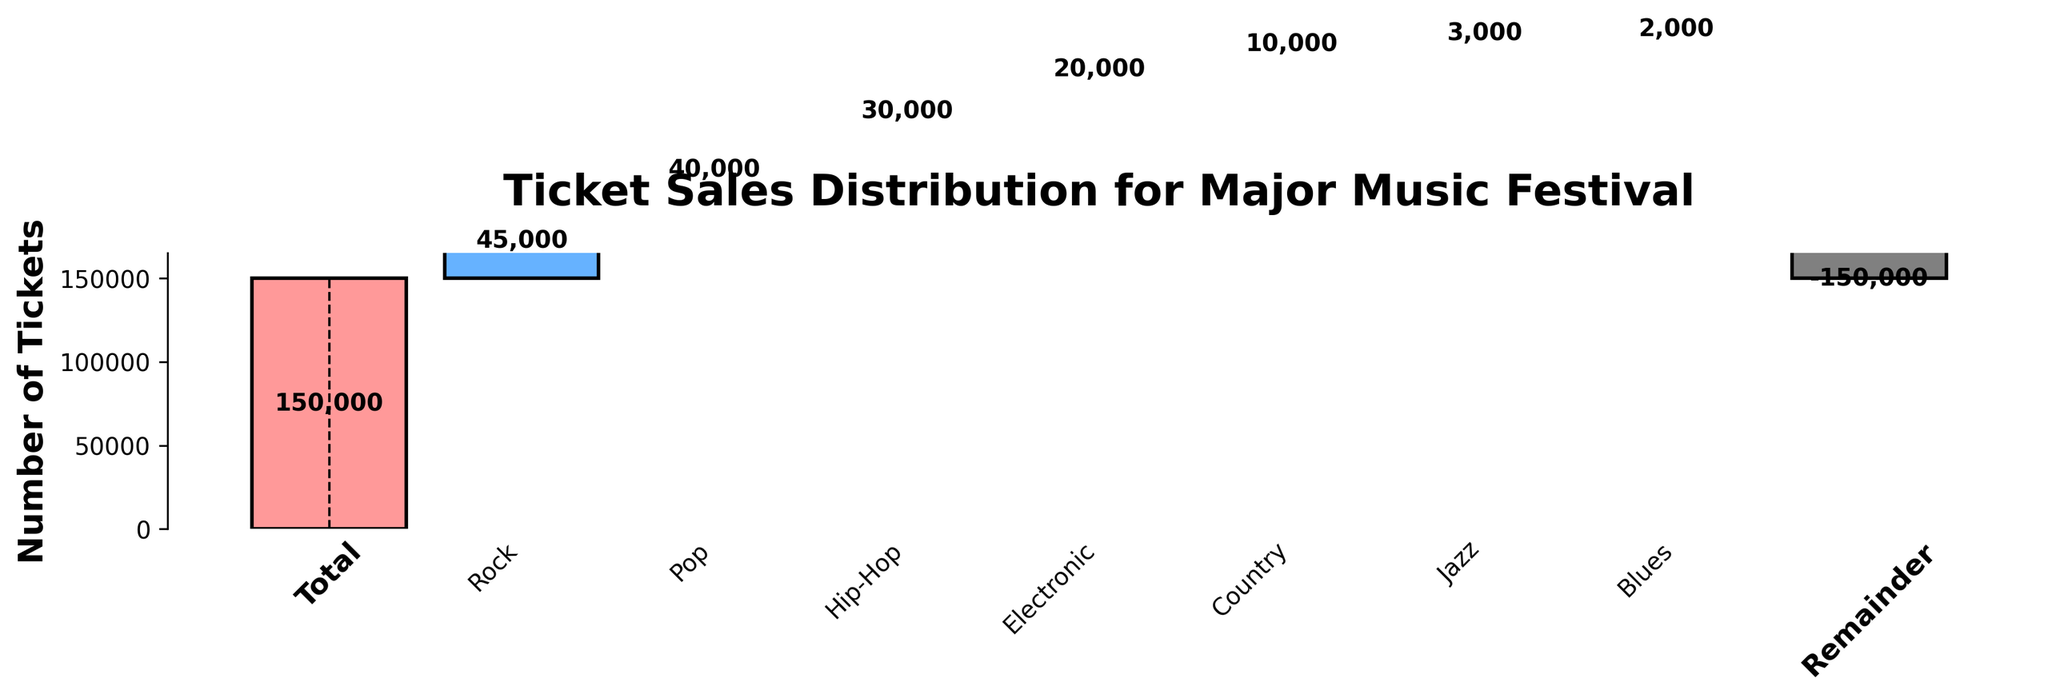What is the title of the chart? The title is usually placed at the top of the chart and provides an overview of what the chart is about.
Answer: Ticket Sales Distribution for Major Music Festival What genre sold the highest number of tickets? The genre with the tallest bar represents the highest number of tickets sold.
Answer: Rock How many tickets were sold for Jazz and Blues combined? Sum the values for Jazz (3000) and Blues (2000). 3000 + 2000 = 5000
Answer: 5000 Which genre had the lowest ticket sales, excluding the 'Total' and 'Remainder' categories? The genre with the smallest positive value or smallest bar represents the lowest ticket sales.
Answer: Blues By how much did Hip-Hop ticket sales differ from Electronic ticket sales? Subtract the number of Electronic tickets sold (20000) from the number of Hip-Hop tickets sold (30000). 30000 - 20000 = 10000
Answer: 10000 Is the cumulative number of tickets sold for Rock and Pop more than half of the total tickets sold? Sum the ticket sales for Rock (45000) and Pop (40000) and compare it to half of the total tickets (75000). 45000 + 40000 = 85000, which is greater than 75000
Answer: Yes Which genre sold 20,000 tickets? Identify the bar labeled with 20,000 tickets.
Answer: Electronic What are the total tickets sold excluding the 'Remainder' portion? Sum all the ticket sales values excluding the 'Remainder'. 45000 + 40000 + 30000 + 20000 + 10000 + 3000 + 2000 = 150000
Answer: 150000 What is the decrement in tickets sold after considering the Remainder? The 'Remainder' value is -150000, which indicates the decrement in tickets sold.
Answer: -150000 What does the 'Remainder' value signify in the chart? The 'Remainder' value adjusts the summed ticket sales of individual genres back to the initial 'Total' value. Since individual genres sum up to 150000, the 'Remainder' corrects it by subtracting 150000 to balance it back to zero.
Answer: Adjusts individual sums to total 